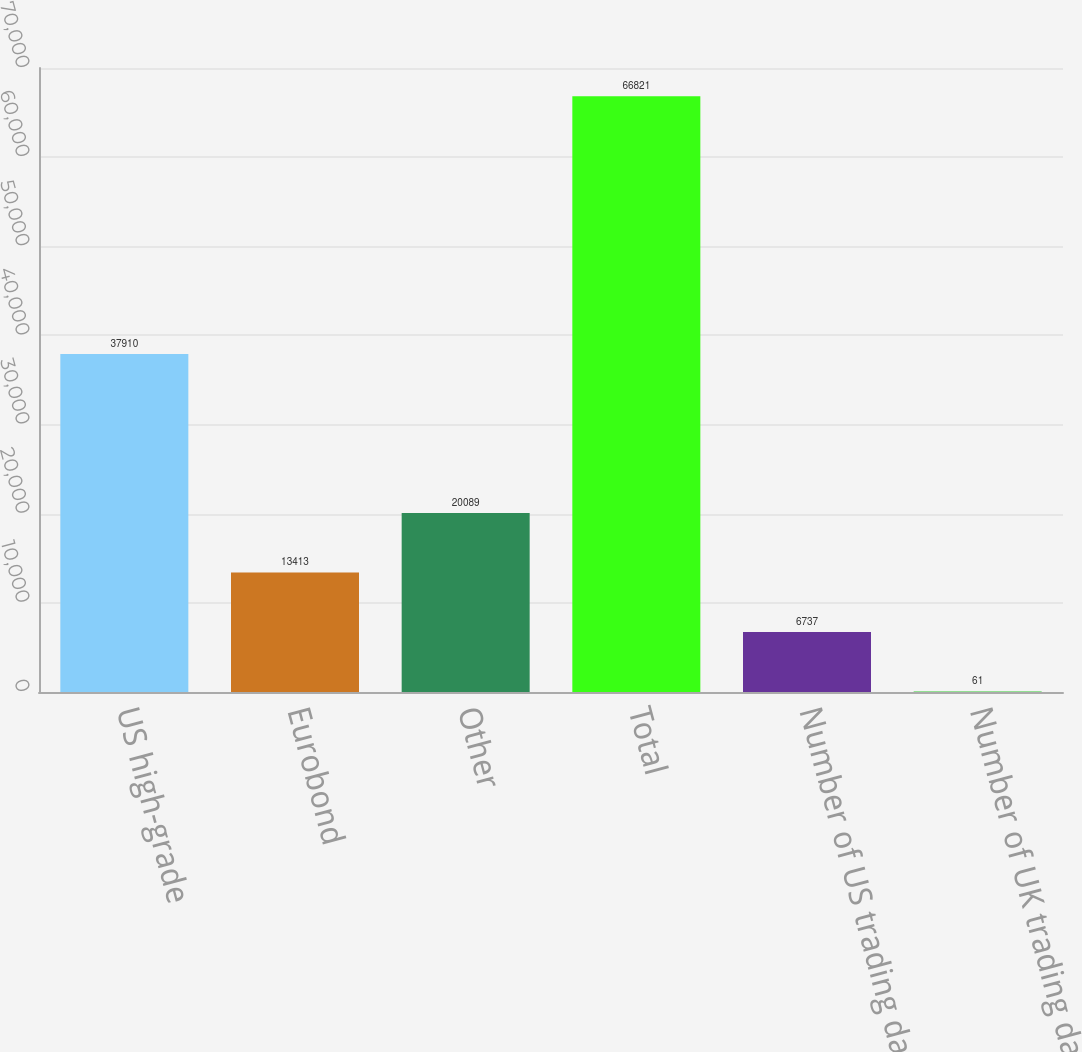Convert chart to OTSL. <chart><loc_0><loc_0><loc_500><loc_500><bar_chart><fcel>US high-grade<fcel>Eurobond<fcel>Other<fcel>Total<fcel>Number of US trading days<fcel>Number of UK trading days<nl><fcel>37910<fcel>13413<fcel>20089<fcel>66821<fcel>6737<fcel>61<nl></chart> 